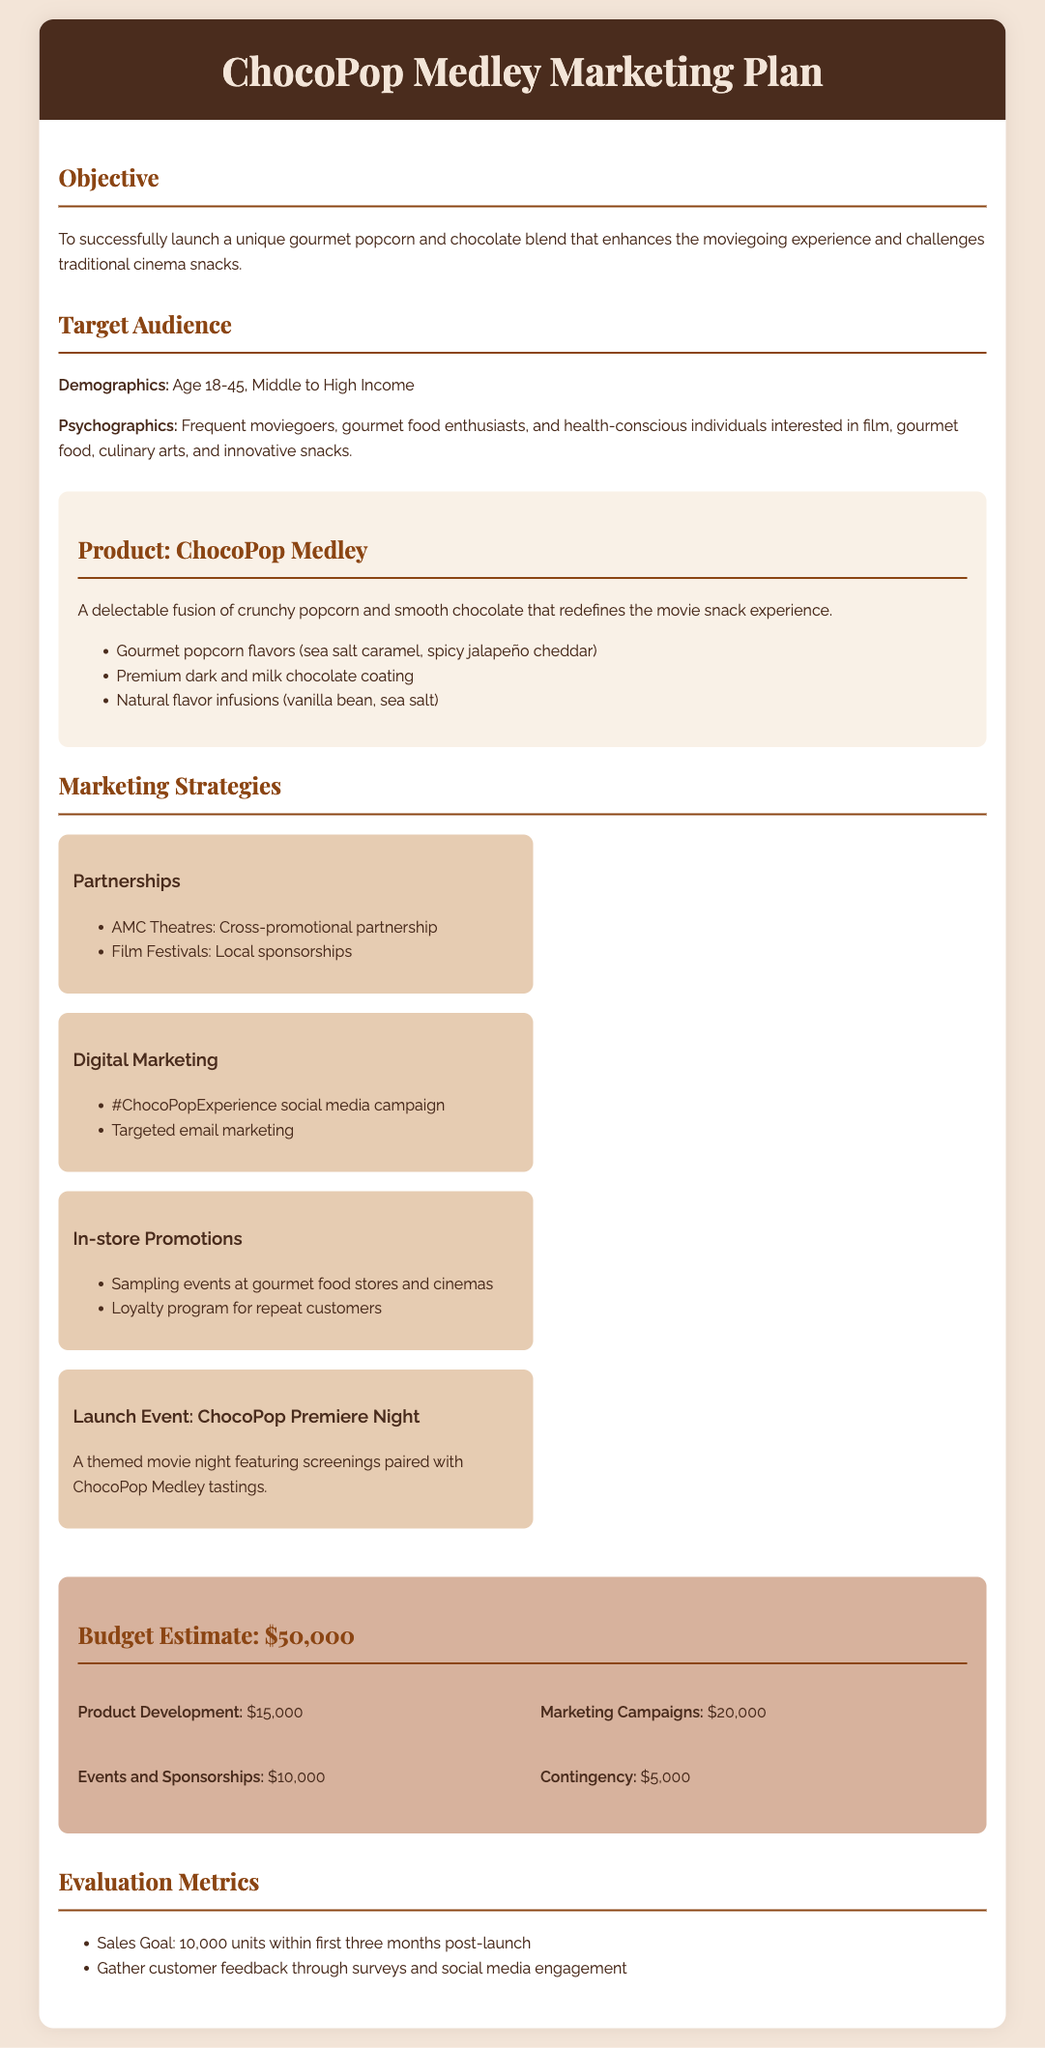what is the title of the marketing plan? The title is the main heading of the document, which reflects the product being marketed.
Answer: ChocoPop Medley Marketing Plan what is the objective of the marketing plan? The objective summarizes the primary goal of the marketing initiative laid out in the document.
Answer: To successfully launch a unique gourmet popcorn and chocolate blend that enhances the moviegoing experience and challenges traditional cinema snacks who is the target audience? The target audience section identifies the demographic and psychographic characteristics of the intended consumers.
Answer: Age 18-45, Middle to High Income what is the estimated budget for the marketing plan? The budget estimate is a specific figure provided in the document for financial planning related to the marketing effort.
Answer: $50,000 what are the gourmet popcorn flavors mentioned? The document lists specific flavors in the product description which highlight the product's uniqueness.
Answer: sea salt caramel, spicy jalapeño cheddar which company is mentioned as a partnership opportunity? The partnerships section identifies organizations that can enhance promotional efforts and reach the target audience.
Answer: AMC Theatres what is one of the evaluation metrics? The evaluation metrics provide ways to measure the success of the marketing plan post-launch.
Answer: Sales Goal: 10,000 units within first three months post-launch what type of event is planned for the launch? The launch event section outlines a specific promotional activity that will attract potential customers.
Answer: ChocoPop Premiere Night what is included in the product description? The product description provides key attributes and components of the ChocoPop Medley, emphasizing its appeal.
Answer: A delectable fusion of crunchy popcorn and smooth chocolate that redefines the movie snack experience 